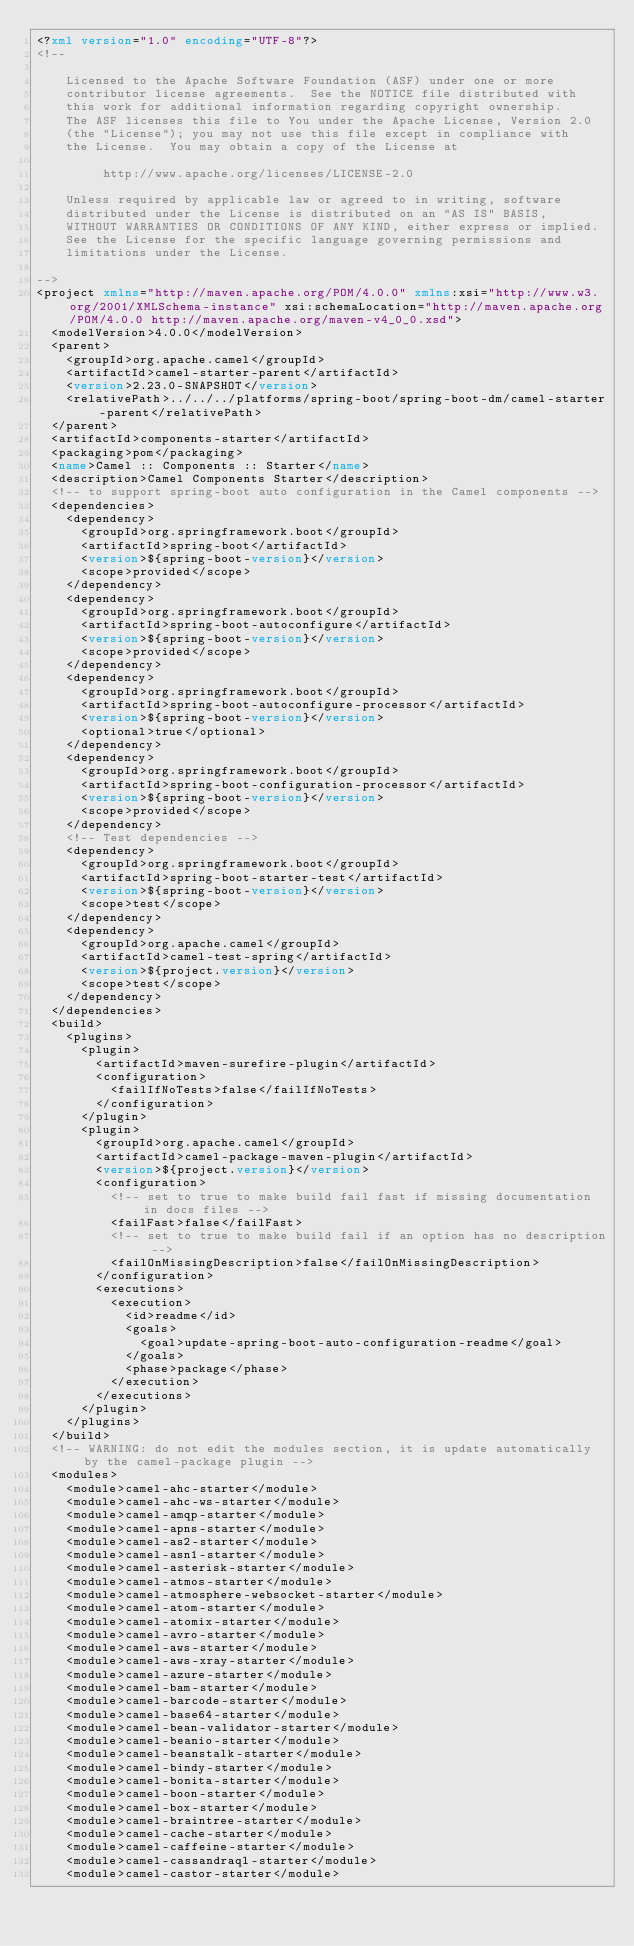Convert code to text. <code><loc_0><loc_0><loc_500><loc_500><_XML_><?xml version="1.0" encoding="UTF-8"?>
<!--

    Licensed to the Apache Software Foundation (ASF) under one or more
    contributor license agreements.  See the NOTICE file distributed with
    this work for additional information regarding copyright ownership.
    The ASF licenses this file to You under the Apache License, Version 2.0
    (the "License"); you may not use this file except in compliance with
    the License.  You may obtain a copy of the License at

         http://www.apache.org/licenses/LICENSE-2.0

    Unless required by applicable law or agreed to in writing, software
    distributed under the License is distributed on an "AS IS" BASIS,
    WITHOUT WARRANTIES OR CONDITIONS OF ANY KIND, either express or implied.
    See the License for the specific language governing permissions and
    limitations under the License.

-->
<project xmlns="http://maven.apache.org/POM/4.0.0" xmlns:xsi="http://www.w3.org/2001/XMLSchema-instance" xsi:schemaLocation="http://maven.apache.org/POM/4.0.0 http://maven.apache.org/maven-v4_0_0.xsd">
  <modelVersion>4.0.0</modelVersion>
  <parent>
    <groupId>org.apache.camel</groupId>
    <artifactId>camel-starter-parent</artifactId>
    <version>2.23.0-SNAPSHOT</version>
    <relativePath>../../../platforms/spring-boot/spring-boot-dm/camel-starter-parent</relativePath>
  </parent>
  <artifactId>components-starter</artifactId>
  <packaging>pom</packaging>
  <name>Camel :: Components :: Starter</name>
  <description>Camel Components Starter</description>
  <!-- to support spring-boot auto configuration in the Camel components -->
  <dependencies>
    <dependency>
      <groupId>org.springframework.boot</groupId>
      <artifactId>spring-boot</artifactId>
      <version>${spring-boot-version}</version>
      <scope>provided</scope>
    </dependency>
    <dependency>
      <groupId>org.springframework.boot</groupId>
      <artifactId>spring-boot-autoconfigure</artifactId>
      <version>${spring-boot-version}</version>
      <scope>provided</scope>
    </dependency>
    <dependency>
      <groupId>org.springframework.boot</groupId>
      <artifactId>spring-boot-autoconfigure-processor</artifactId>
      <version>${spring-boot-version}</version>
      <optional>true</optional>
    </dependency>
    <dependency>
      <groupId>org.springframework.boot</groupId>
      <artifactId>spring-boot-configuration-processor</artifactId>
      <version>${spring-boot-version}</version>
      <scope>provided</scope>
    </dependency>
    <!-- Test dependencies -->
    <dependency>
      <groupId>org.springframework.boot</groupId>
      <artifactId>spring-boot-starter-test</artifactId>
      <version>${spring-boot-version}</version>
      <scope>test</scope>
    </dependency>
    <dependency>
      <groupId>org.apache.camel</groupId>
      <artifactId>camel-test-spring</artifactId>
      <version>${project.version}</version>
      <scope>test</scope>
    </dependency>
  </dependencies>
  <build>
    <plugins>
      <plugin>
        <artifactId>maven-surefire-plugin</artifactId>
        <configuration>
          <failIfNoTests>false</failIfNoTests>
        </configuration>
      </plugin>
      <plugin>
        <groupId>org.apache.camel</groupId>
        <artifactId>camel-package-maven-plugin</artifactId>
        <version>${project.version}</version>
        <configuration>
          <!-- set to true to make build fail fast if missing documentation in docs files -->
          <failFast>false</failFast>
          <!-- set to true to make build fail if an option has no description -->
          <failOnMissingDescription>false</failOnMissingDescription>
        </configuration>
        <executions>
          <execution>
            <id>readme</id>
            <goals>
              <goal>update-spring-boot-auto-configuration-readme</goal>
            </goals>
            <phase>package</phase>
          </execution>
        </executions>
      </plugin>
    </plugins>
  </build>
  <!-- WARNING: do not edit the modules section, it is update automatically by the camel-package plugin -->
  <modules>
    <module>camel-ahc-starter</module>
    <module>camel-ahc-ws-starter</module>
    <module>camel-amqp-starter</module>
    <module>camel-apns-starter</module>
    <module>camel-as2-starter</module>
    <module>camel-asn1-starter</module>
    <module>camel-asterisk-starter</module>
    <module>camel-atmos-starter</module>
    <module>camel-atmosphere-websocket-starter</module>
    <module>camel-atom-starter</module>
    <module>camel-atomix-starter</module>
    <module>camel-avro-starter</module>
    <module>camel-aws-starter</module>
    <module>camel-aws-xray-starter</module>
    <module>camel-azure-starter</module>
    <module>camel-bam-starter</module>
    <module>camel-barcode-starter</module>
    <module>camel-base64-starter</module>
    <module>camel-bean-validator-starter</module>
    <module>camel-beanio-starter</module>
    <module>camel-beanstalk-starter</module>
    <module>camel-bindy-starter</module>
    <module>camel-bonita-starter</module>
    <module>camel-boon-starter</module>
    <module>camel-box-starter</module>
    <module>camel-braintree-starter</module>
    <module>camel-cache-starter</module>
    <module>camel-caffeine-starter</module>
    <module>camel-cassandraql-starter</module>
    <module>camel-castor-starter</module></code> 